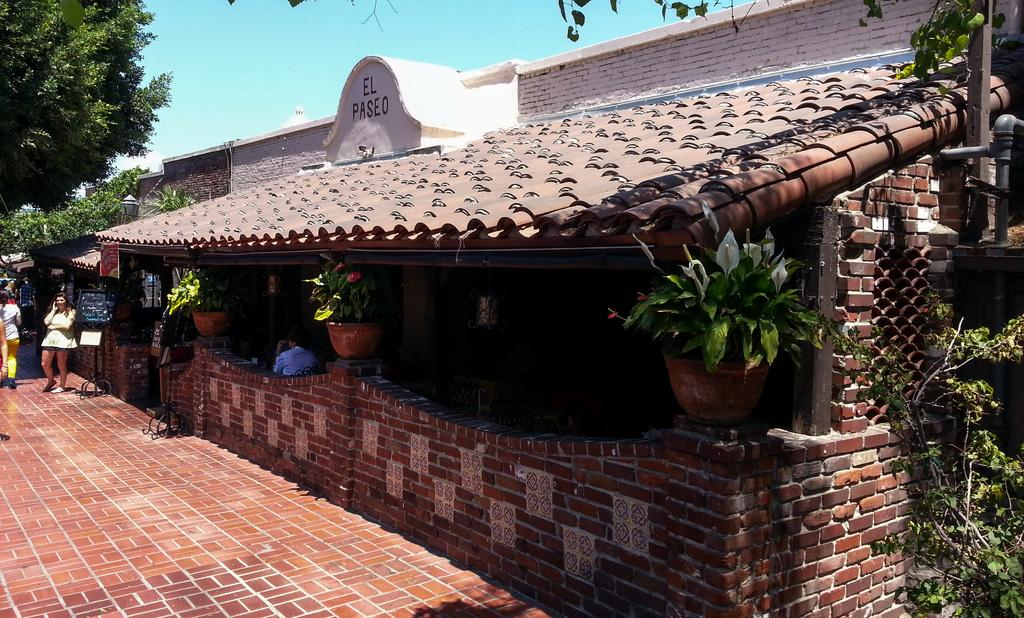What is the main subject of the image? There is a person standing in the image. What is the person wearing? The person is wearing a white dress. What type of vegetation can be seen in the image? There are plants in the image. What is the color of the plants? The plants are green. What is visible in the background of the image? The sky is visible in the image. What is the color of the sky? The sky is blue. What type of sense can be seen in the image? There is no sense visible in the image; it features a person standing, plants, and a blue sky. What type of underwear is the person wearing in the image? The image does not show the person's underwear, so it cannot be determined from the image. 